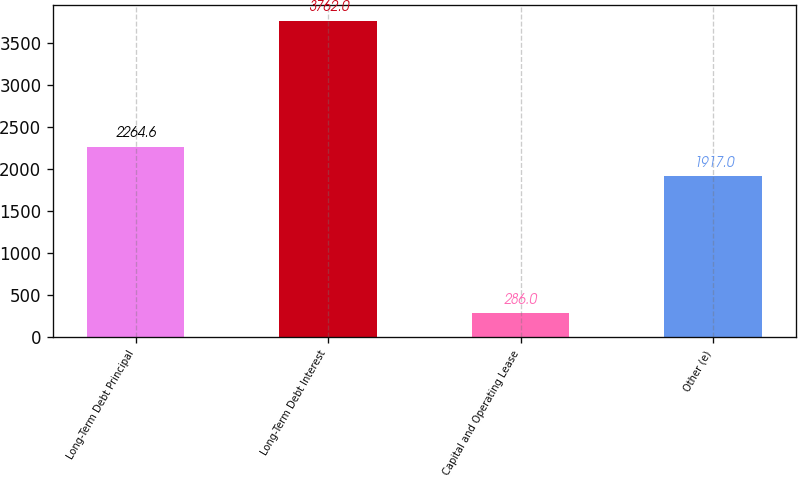Convert chart to OTSL. <chart><loc_0><loc_0><loc_500><loc_500><bar_chart><fcel>Long-Term Debt Principal<fcel>Long-Term Debt Interest<fcel>Capital and Operating Lease<fcel>Other (e)<nl><fcel>2264.6<fcel>3762<fcel>286<fcel>1917<nl></chart> 